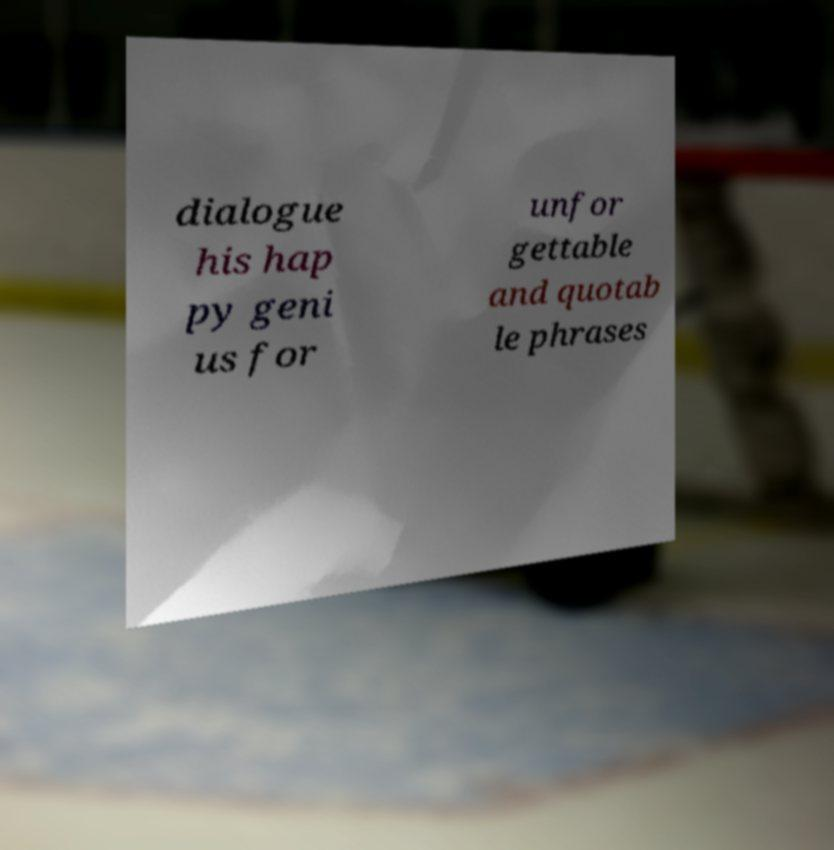Could you assist in decoding the text presented in this image and type it out clearly? dialogue his hap py geni us for unfor gettable and quotab le phrases 